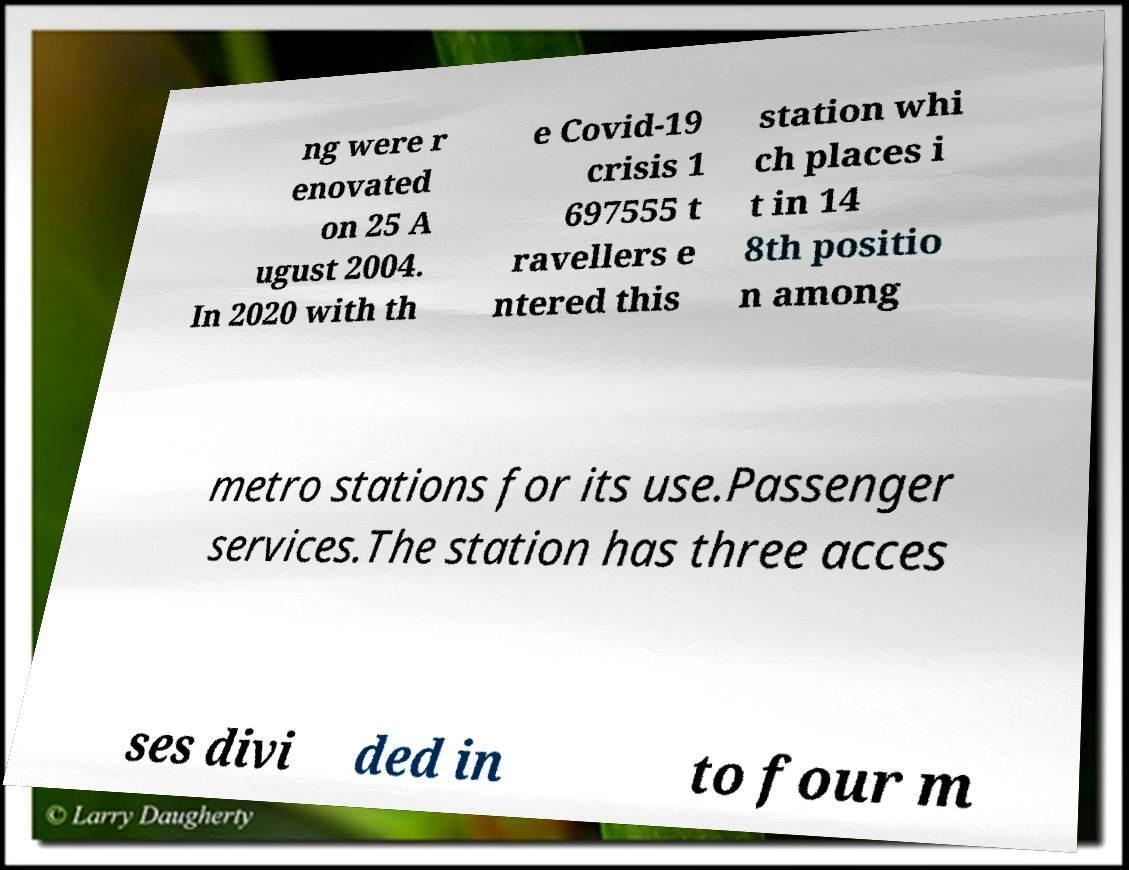Please identify and transcribe the text found in this image. ng were r enovated on 25 A ugust 2004. In 2020 with th e Covid-19 crisis 1 697555 t ravellers e ntered this station whi ch places i t in 14 8th positio n among metro stations for its use.Passenger services.The station has three acces ses divi ded in to four m 